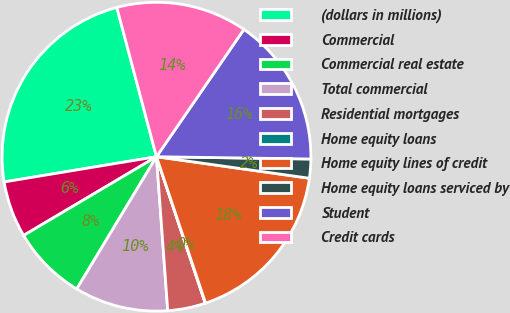Convert chart. <chart><loc_0><loc_0><loc_500><loc_500><pie_chart><fcel>(dollars in millions)<fcel>Commercial<fcel>Commercial real estate<fcel>Total commercial<fcel>Residential mortgages<fcel>Home equity loans<fcel>Home equity lines of credit<fcel>Home equity loans serviced by<fcel>Student<fcel>Credit cards<nl><fcel>23.48%<fcel>5.9%<fcel>7.85%<fcel>9.8%<fcel>3.95%<fcel>0.04%<fcel>17.62%<fcel>1.99%<fcel>15.66%<fcel>13.71%<nl></chart> 